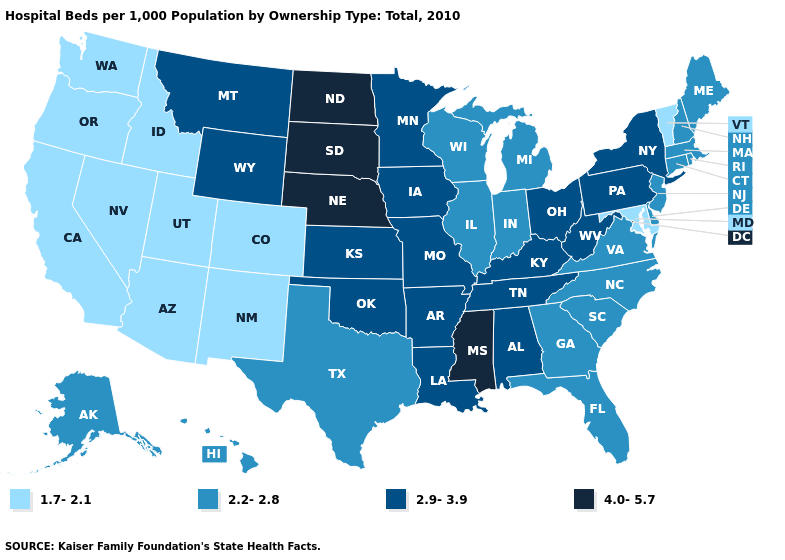Does Kansas have a higher value than Indiana?
Answer briefly. Yes. Which states hav the highest value in the Northeast?
Quick response, please. New York, Pennsylvania. Name the states that have a value in the range 2.9-3.9?
Be succinct. Alabama, Arkansas, Iowa, Kansas, Kentucky, Louisiana, Minnesota, Missouri, Montana, New York, Ohio, Oklahoma, Pennsylvania, Tennessee, West Virginia, Wyoming. What is the value of Ohio?
Answer briefly. 2.9-3.9. Does Maine have the lowest value in the USA?
Quick response, please. No. Does South Dakota have a higher value than Louisiana?
Short answer required. Yes. What is the value of West Virginia?
Quick response, please. 2.9-3.9. Does Virginia have the highest value in the USA?
Quick response, please. No. Does the first symbol in the legend represent the smallest category?
Keep it brief. Yes. Among the states that border Georgia , does Alabama have the highest value?
Answer briefly. Yes. Name the states that have a value in the range 2.2-2.8?
Quick response, please. Alaska, Connecticut, Delaware, Florida, Georgia, Hawaii, Illinois, Indiana, Maine, Massachusetts, Michigan, New Hampshire, New Jersey, North Carolina, Rhode Island, South Carolina, Texas, Virginia, Wisconsin. Name the states that have a value in the range 2.9-3.9?
Answer briefly. Alabama, Arkansas, Iowa, Kansas, Kentucky, Louisiana, Minnesota, Missouri, Montana, New York, Ohio, Oklahoma, Pennsylvania, Tennessee, West Virginia, Wyoming. Name the states that have a value in the range 1.7-2.1?
Give a very brief answer. Arizona, California, Colorado, Idaho, Maryland, Nevada, New Mexico, Oregon, Utah, Vermont, Washington. Is the legend a continuous bar?
Quick response, please. No. 